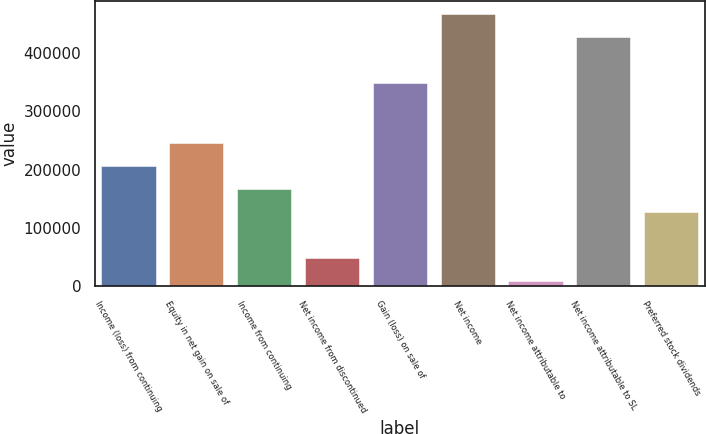<chart> <loc_0><loc_0><loc_500><loc_500><bar_chart><fcel>Income (loss) from continuing<fcel>Equity in net gain on sale of<fcel>Income from continuing<fcel>Net income from discontinued<fcel>Gain (loss) on sale of<fcel>Net income<fcel>Net income attributable to<fcel>Net income attributable to SL<fcel>Preferred stock dividends<nl><fcel>206362<fcel>245900<fcel>166825<fcel>48214.1<fcel>348573<fcel>467184<fcel>8677<fcel>427647<fcel>127288<nl></chart> 